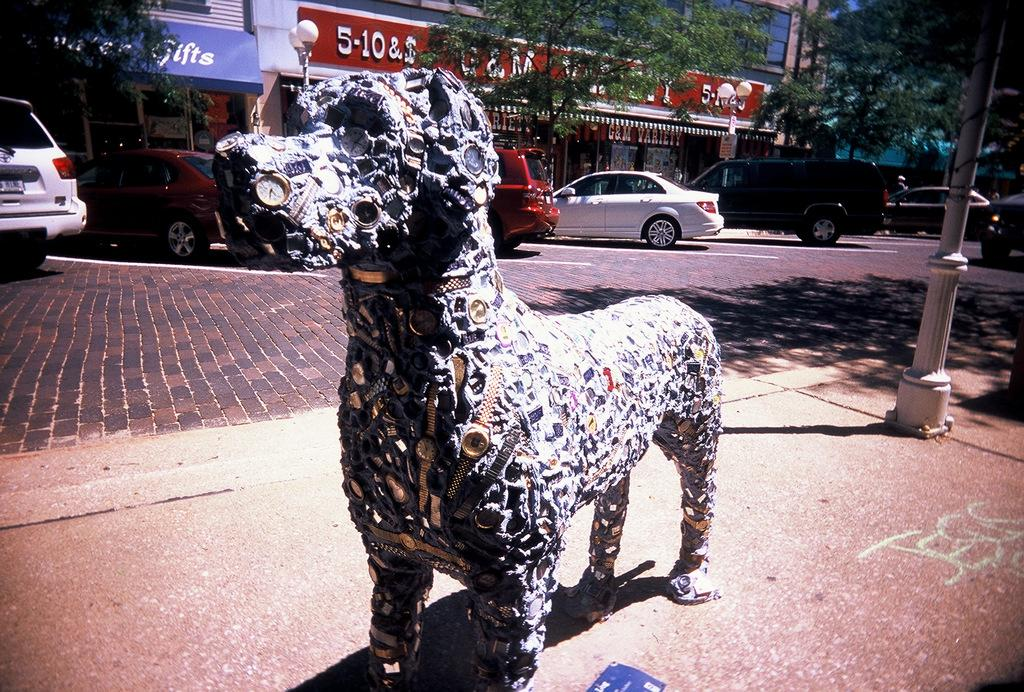What is the main subject in the middle of the image? There is a statue in the middle of the image. What can be seen in the background of the image? There are vehicles, trees, boards, and buildings in the background of the image. What type of substance is the scarecrow holding in the image? There is no scarecrow present in the image, so it is not possible to determine what substance it might be holding. 